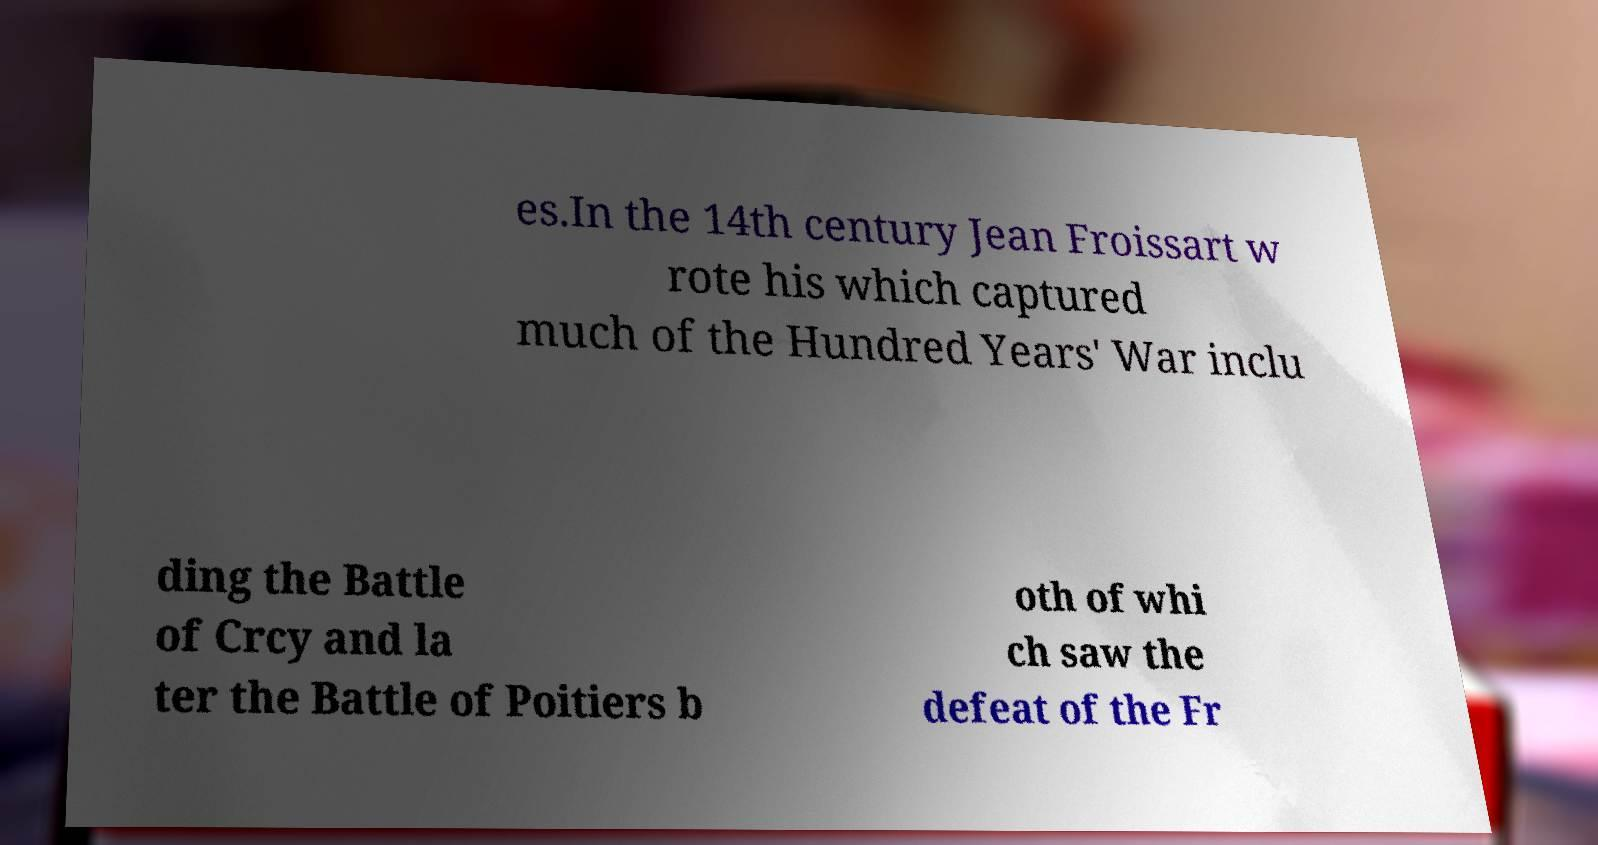There's text embedded in this image that I need extracted. Can you transcribe it verbatim? es.In the 14th century Jean Froissart w rote his which captured much of the Hundred Years' War inclu ding the Battle of Crcy and la ter the Battle of Poitiers b oth of whi ch saw the defeat of the Fr 